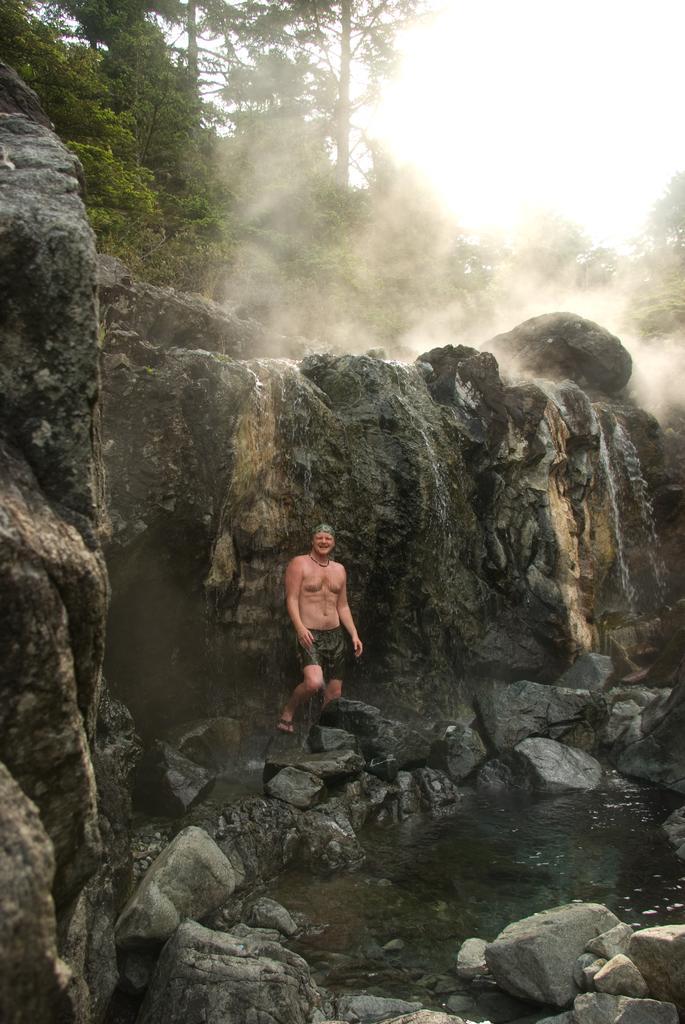How would you summarize this image in a sentence or two? In this image I can see number of stores and in the center of the image I can see a man is standing. I can see he is wearing a shorts and a slipper. On the top side of the image I can see the smoke, number of trees and the sky. On the bottom right side of the image I can see water. 